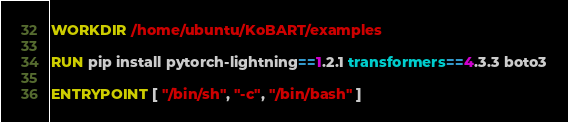Convert code to text. <code><loc_0><loc_0><loc_500><loc_500><_Dockerfile_>
WORKDIR /home/ubuntu/KoBART/examples

RUN pip install pytorch-lightning==1.2.1 transformers==4.3.3 boto3

ENTRYPOINT [ "/bin/sh", "-c", "/bin/bash" ]
</code> 